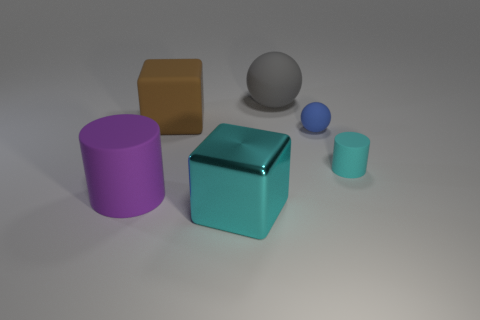Are there any other things that are the same material as the large cyan thing?
Offer a terse response. No. What is the size of the matte cylinder that is the same color as the metal cube?
Keep it short and to the point. Small. What is the material of the big cyan cube?
Your answer should be very brief. Metal. What shape is the cyan thing that is behind the big purple object?
Offer a very short reply. Cylinder. There is a metallic thing that is the same size as the gray rubber thing; what color is it?
Your answer should be very brief. Cyan. Is the tiny cyan cylinder that is right of the gray matte object made of the same material as the tiny blue thing?
Ensure brevity in your answer.  Yes. What is the size of the object that is in front of the small cyan thing and right of the brown rubber cube?
Your answer should be very brief. Large. What is the size of the cube behind the metal cube?
Ensure brevity in your answer.  Large. What shape is the other thing that is the same color as the large metal thing?
Make the answer very short. Cylinder. What is the shape of the big thing in front of the big thing that is to the left of the large block on the left side of the large shiny cube?
Ensure brevity in your answer.  Cube. 